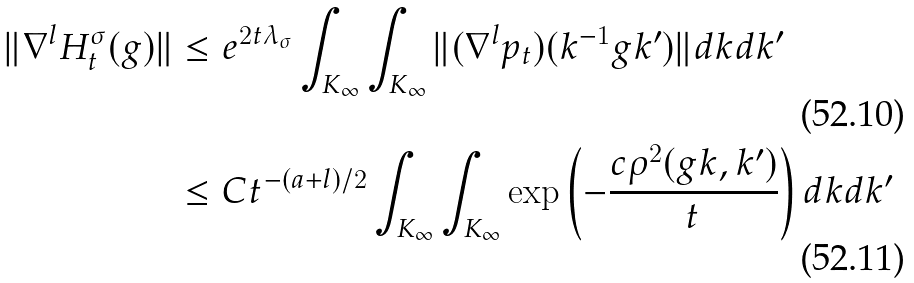Convert formula to latex. <formula><loc_0><loc_0><loc_500><loc_500>\| \nabla ^ { l } H _ { t } ^ { \sigma } ( g ) \| & \leq e ^ { 2 t \lambda _ { \sigma } } \int _ { K _ { \infty } } \int _ { K _ { \infty } } \| ( \nabla ^ { l } p _ { t } ) ( k ^ { - 1 } g k ^ { \prime } ) \| d k d k ^ { \prime } \\ & \leq C t ^ { - ( a + l ) / 2 } \int _ { K _ { \infty } } \int _ { K _ { \infty } } \exp \left ( - \frac { c \rho ^ { 2 } ( g k , k ^ { \prime } ) } { t } \right ) d k d k ^ { \prime }</formula> 